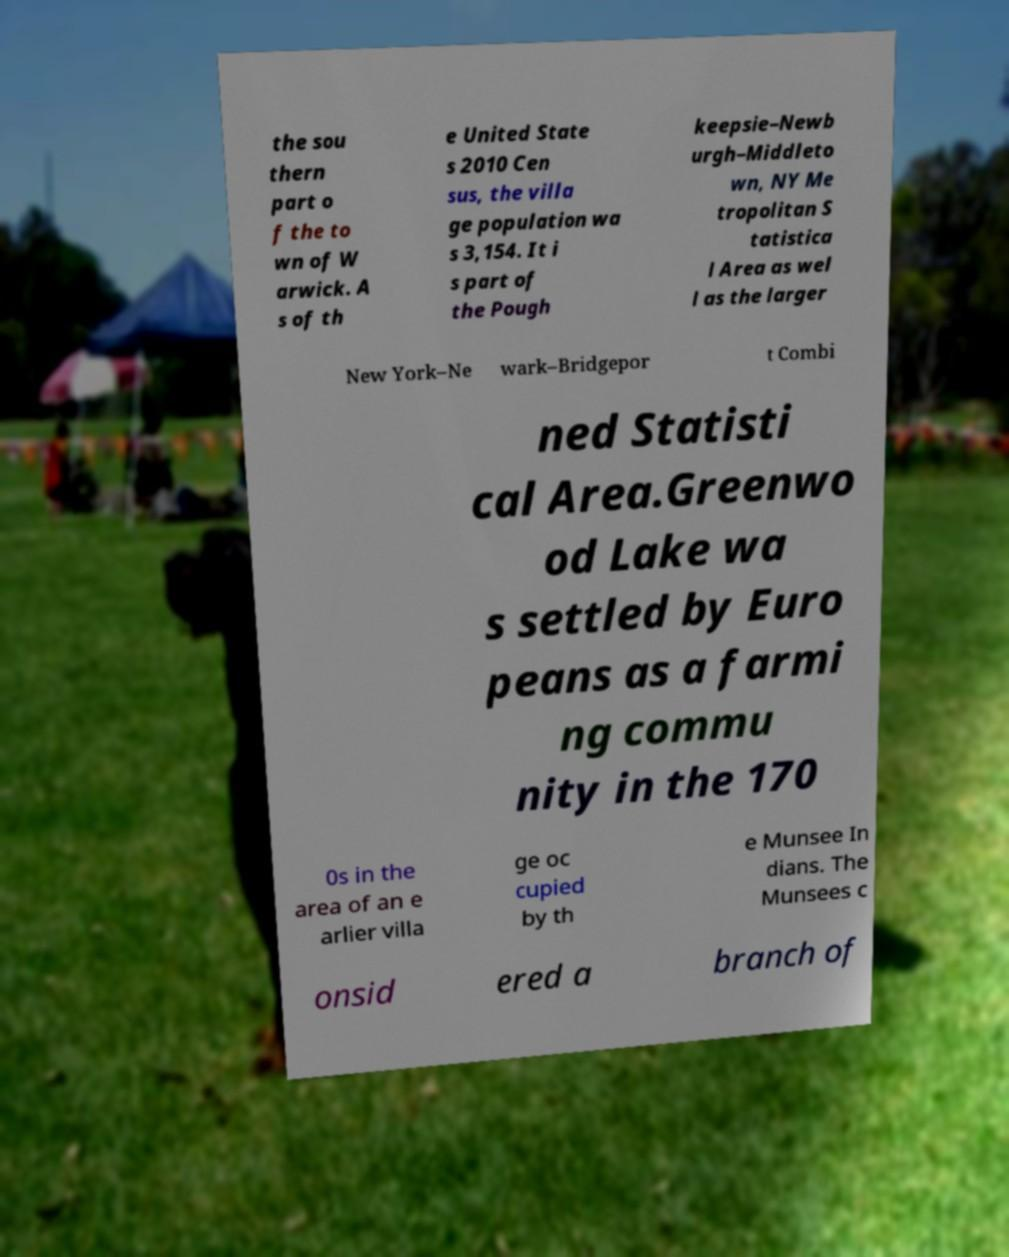There's text embedded in this image that I need extracted. Can you transcribe it verbatim? the sou thern part o f the to wn of W arwick. A s of th e United State s 2010 Cen sus, the villa ge population wa s 3,154. It i s part of the Pough keepsie–Newb urgh–Middleto wn, NY Me tropolitan S tatistica l Area as wel l as the larger New York–Ne wark–Bridgepor t Combi ned Statisti cal Area.Greenwo od Lake wa s settled by Euro peans as a farmi ng commu nity in the 170 0s in the area of an e arlier villa ge oc cupied by th e Munsee In dians. The Munsees c onsid ered a branch of 